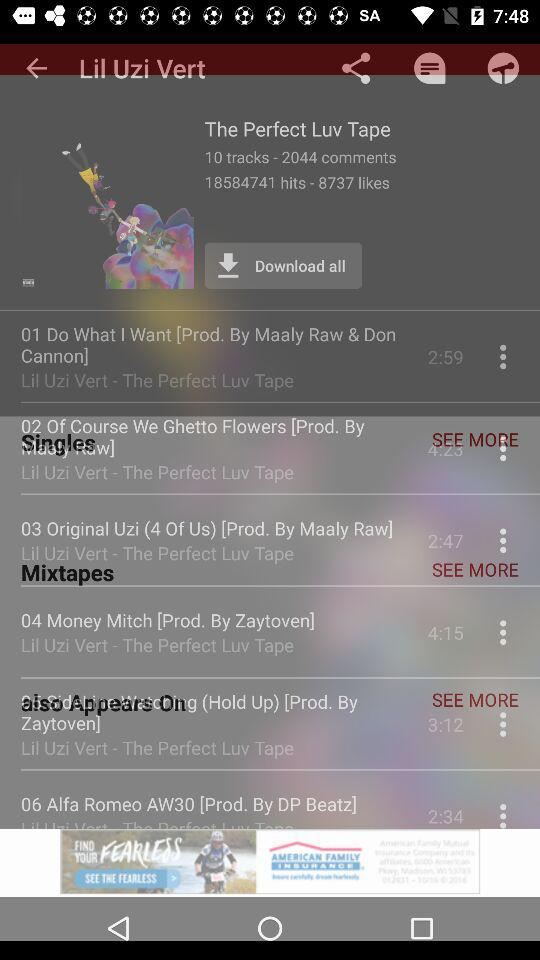How many tracks are in "The Perfect Luv Tape"? There are 10 tracks. 